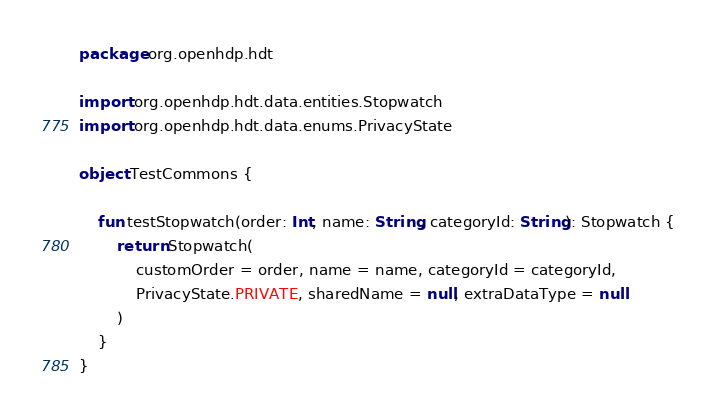Convert code to text. <code><loc_0><loc_0><loc_500><loc_500><_Kotlin_>package org.openhdp.hdt

import org.openhdp.hdt.data.entities.Stopwatch
import org.openhdp.hdt.data.enums.PrivacyState

object TestCommons {

    fun testStopwatch(order: Int, name: String, categoryId: String): Stopwatch {
        return Stopwatch(
            customOrder = order, name = name, categoryId = categoryId,
            PrivacyState.PRIVATE, sharedName = null, extraDataType = null
        )
    }
}</code> 